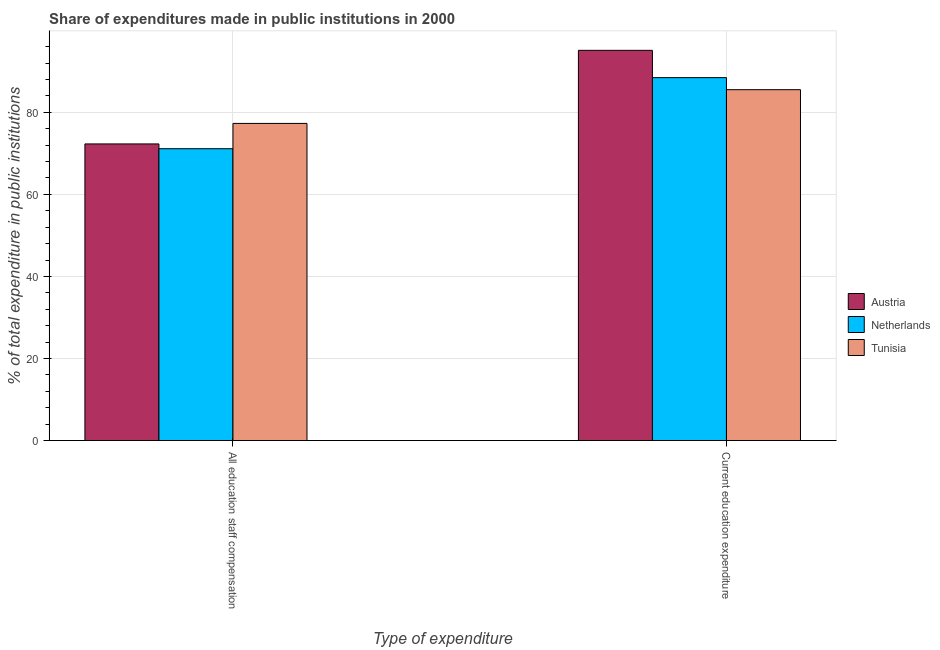How many groups of bars are there?
Offer a very short reply. 2. What is the label of the 2nd group of bars from the left?
Provide a succinct answer. Current education expenditure. What is the expenditure in education in Tunisia?
Keep it short and to the point. 85.51. Across all countries, what is the maximum expenditure in staff compensation?
Make the answer very short. 77.3. Across all countries, what is the minimum expenditure in staff compensation?
Make the answer very short. 71.13. In which country was the expenditure in staff compensation maximum?
Ensure brevity in your answer.  Tunisia. In which country was the expenditure in staff compensation minimum?
Your answer should be compact. Netherlands. What is the total expenditure in staff compensation in the graph?
Give a very brief answer. 220.72. What is the difference between the expenditure in education in Austria and that in Netherlands?
Keep it short and to the point. 6.65. What is the difference between the expenditure in education in Netherlands and the expenditure in staff compensation in Austria?
Offer a terse response. 16.16. What is the average expenditure in staff compensation per country?
Keep it short and to the point. 73.57. What is the difference between the expenditure in education and expenditure in staff compensation in Austria?
Your answer should be compact. 22.81. In how many countries, is the expenditure in education greater than 56 %?
Ensure brevity in your answer.  3. What is the ratio of the expenditure in staff compensation in Austria to that in Tunisia?
Offer a very short reply. 0.94. Is the expenditure in education in Tunisia less than that in Netherlands?
Offer a terse response. Yes. In how many countries, is the expenditure in education greater than the average expenditure in education taken over all countries?
Your answer should be compact. 1. What does the 3rd bar from the right in Current education expenditure represents?
Provide a short and direct response. Austria. How many bars are there?
Provide a succinct answer. 6. Are all the bars in the graph horizontal?
Ensure brevity in your answer.  No. How many countries are there in the graph?
Offer a very short reply. 3. Are the values on the major ticks of Y-axis written in scientific E-notation?
Provide a short and direct response. No. Does the graph contain any zero values?
Your response must be concise. No. What is the title of the graph?
Provide a succinct answer. Share of expenditures made in public institutions in 2000. Does "Vanuatu" appear as one of the legend labels in the graph?
Make the answer very short. No. What is the label or title of the X-axis?
Make the answer very short. Type of expenditure. What is the label or title of the Y-axis?
Your response must be concise. % of total expenditure in public institutions. What is the % of total expenditure in public institutions in Austria in All education staff compensation?
Provide a short and direct response. 72.29. What is the % of total expenditure in public institutions of Netherlands in All education staff compensation?
Offer a very short reply. 71.13. What is the % of total expenditure in public institutions in Tunisia in All education staff compensation?
Keep it short and to the point. 77.3. What is the % of total expenditure in public institutions of Austria in Current education expenditure?
Make the answer very short. 95.1. What is the % of total expenditure in public institutions in Netherlands in Current education expenditure?
Give a very brief answer. 88.45. What is the % of total expenditure in public institutions of Tunisia in Current education expenditure?
Offer a terse response. 85.51. Across all Type of expenditure, what is the maximum % of total expenditure in public institutions in Austria?
Keep it short and to the point. 95.1. Across all Type of expenditure, what is the maximum % of total expenditure in public institutions of Netherlands?
Your answer should be compact. 88.45. Across all Type of expenditure, what is the maximum % of total expenditure in public institutions in Tunisia?
Give a very brief answer. 85.51. Across all Type of expenditure, what is the minimum % of total expenditure in public institutions in Austria?
Give a very brief answer. 72.29. Across all Type of expenditure, what is the minimum % of total expenditure in public institutions in Netherlands?
Offer a very short reply. 71.13. Across all Type of expenditure, what is the minimum % of total expenditure in public institutions of Tunisia?
Your response must be concise. 77.3. What is the total % of total expenditure in public institutions in Austria in the graph?
Ensure brevity in your answer.  167.4. What is the total % of total expenditure in public institutions in Netherlands in the graph?
Provide a succinct answer. 159.58. What is the total % of total expenditure in public institutions in Tunisia in the graph?
Ensure brevity in your answer.  162.81. What is the difference between the % of total expenditure in public institutions of Austria in All education staff compensation and that in Current education expenditure?
Offer a very short reply. -22.81. What is the difference between the % of total expenditure in public institutions of Netherlands in All education staff compensation and that in Current education expenditure?
Provide a succinct answer. -17.32. What is the difference between the % of total expenditure in public institutions in Tunisia in All education staff compensation and that in Current education expenditure?
Give a very brief answer. -8.22. What is the difference between the % of total expenditure in public institutions of Austria in All education staff compensation and the % of total expenditure in public institutions of Netherlands in Current education expenditure?
Provide a short and direct response. -16.16. What is the difference between the % of total expenditure in public institutions in Austria in All education staff compensation and the % of total expenditure in public institutions in Tunisia in Current education expenditure?
Ensure brevity in your answer.  -13.22. What is the difference between the % of total expenditure in public institutions of Netherlands in All education staff compensation and the % of total expenditure in public institutions of Tunisia in Current education expenditure?
Make the answer very short. -14.39. What is the average % of total expenditure in public institutions in Austria per Type of expenditure?
Your response must be concise. 83.7. What is the average % of total expenditure in public institutions of Netherlands per Type of expenditure?
Your answer should be very brief. 79.79. What is the average % of total expenditure in public institutions of Tunisia per Type of expenditure?
Offer a very short reply. 81.41. What is the difference between the % of total expenditure in public institutions in Austria and % of total expenditure in public institutions in Netherlands in All education staff compensation?
Offer a terse response. 1.17. What is the difference between the % of total expenditure in public institutions in Austria and % of total expenditure in public institutions in Tunisia in All education staff compensation?
Offer a terse response. -5. What is the difference between the % of total expenditure in public institutions in Netherlands and % of total expenditure in public institutions in Tunisia in All education staff compensation?
Your response must be concise. -6.17. What is the difference between the % of total expenditure in public institutions of Austria and % of total expenditure in public institutions of Netherlands in Current education expenditure?
Keep it short and to the point. 6.65. What is the difference between the % of total expenditure in public institutions of Austria and % of total expenditure in public institutions of Tunisia in Current education expenditure?
Ensure brevity in your answer.  9.59. What is the difference between the % of total expenditure in public institutions of Netherlands and % of total expenditure in public institutions of Tunisia in Current education expenditure?
Ensure brevity in your answer.  2.93. What is the ratio of the % of total expenditure in public institutions in Austria in All education staff compensation to that in Current education expenditure?
Provide a short and direct response. 0.76. What is the ratio of the % of total expenditure in public institutions in Netherlands in All education staff compensation to that in Current education expenditure?
Provide a short and direct response. 0.8. What is the ratio of the % of total expenditure in public institutions of Tunisia in All education staff compensation to that in Current education expenditure?
Offer a very short reply. 0.9. What is the difference between the highest and the second highest % of total expenditure in public institutions of Austria?
Provide a short and direct response. 22.81. What is the difference between the highest and the second highest % of total expenditure in public institutions of Netherlands?
Ensure brevity in your answer.  17.32. What is the difference between the highest and the second highest % of total expenditure in public institutions in Tunisia?
Your answer should be compact. 8.22. What is the difference between the highest and the lowest % of total expenditure in public institutions in Austria?
Ensure brevity in your answer.  22.81. What is the difference between the highest and the lowest % of total expenditure in public institutions in Netherlands?
Ensure brevity in your answer.  17.32. What is the difference between the highest and the lowest % of total expenditure in public institutions in Tunisia?
Your answer should be very brief. 8.22. 